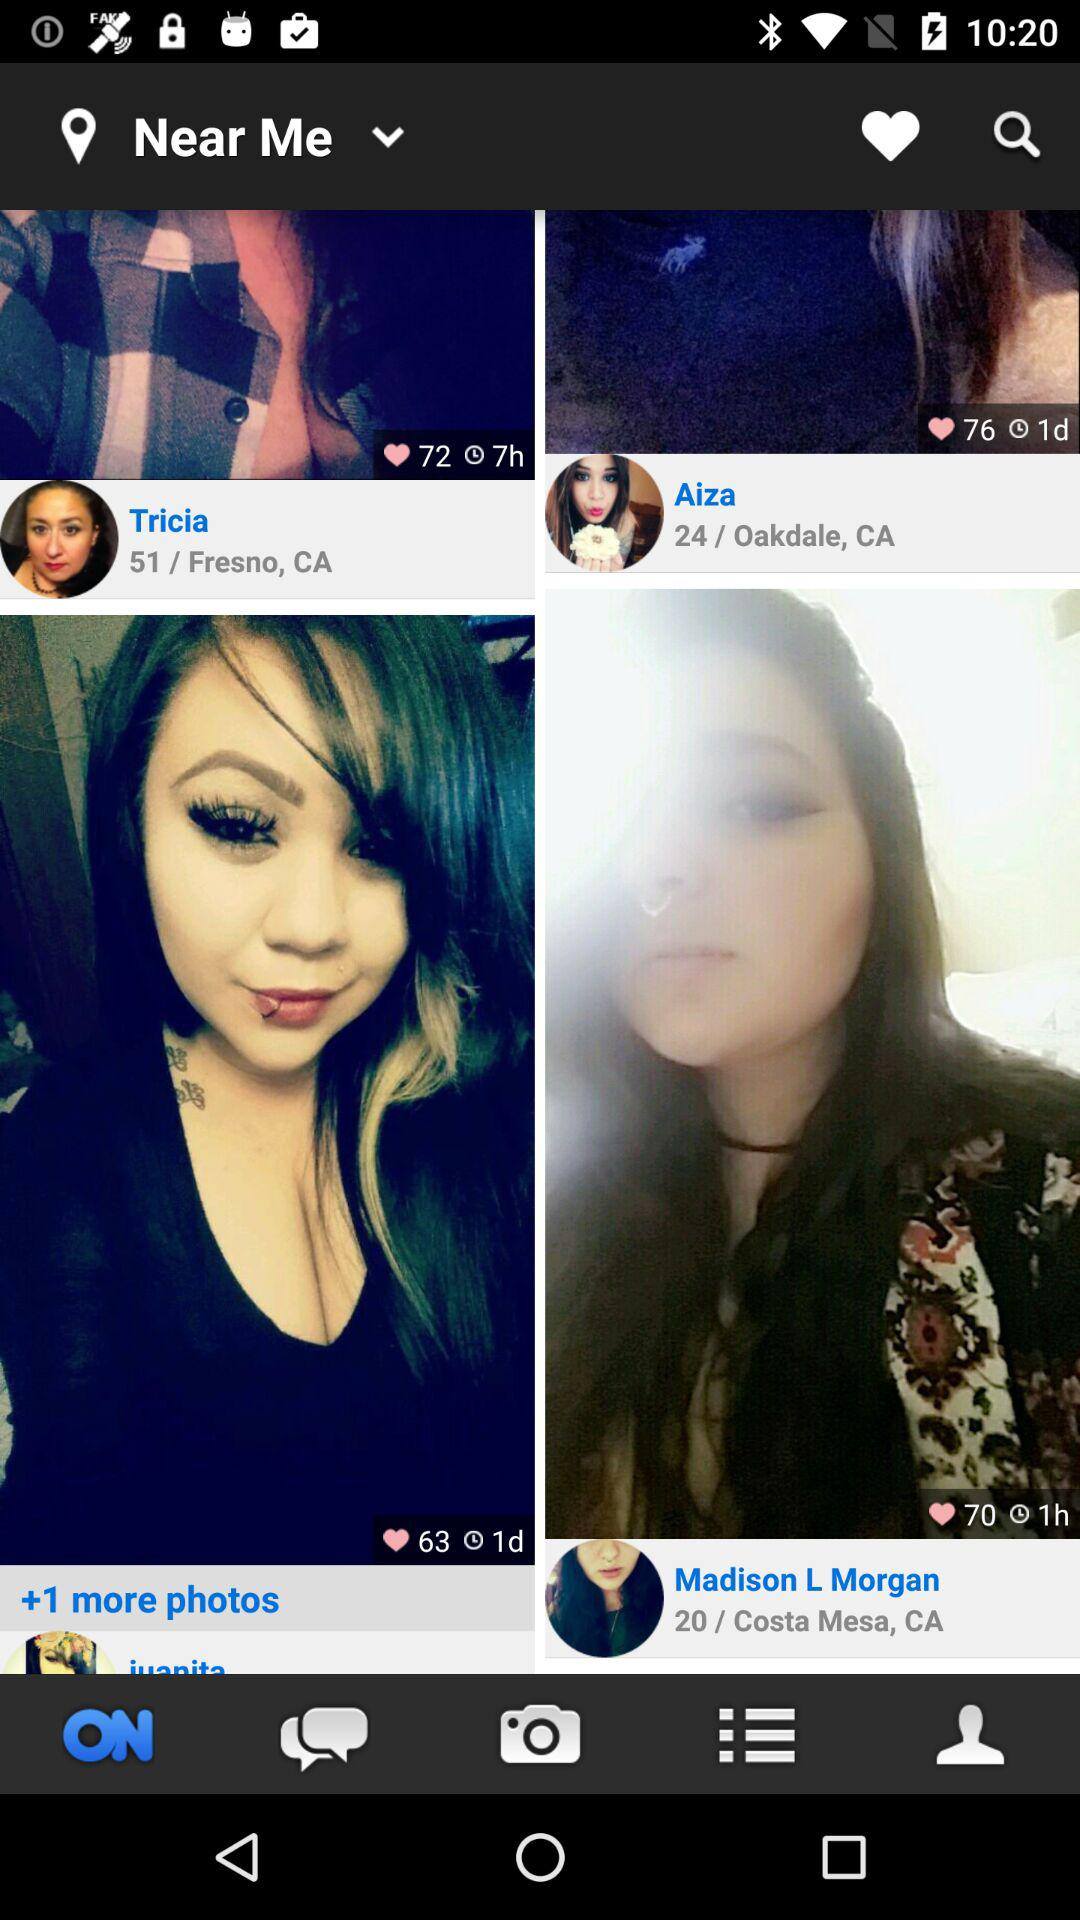How many people like the photo of Aiza? The people who liked the photo of Aiza are 76. 